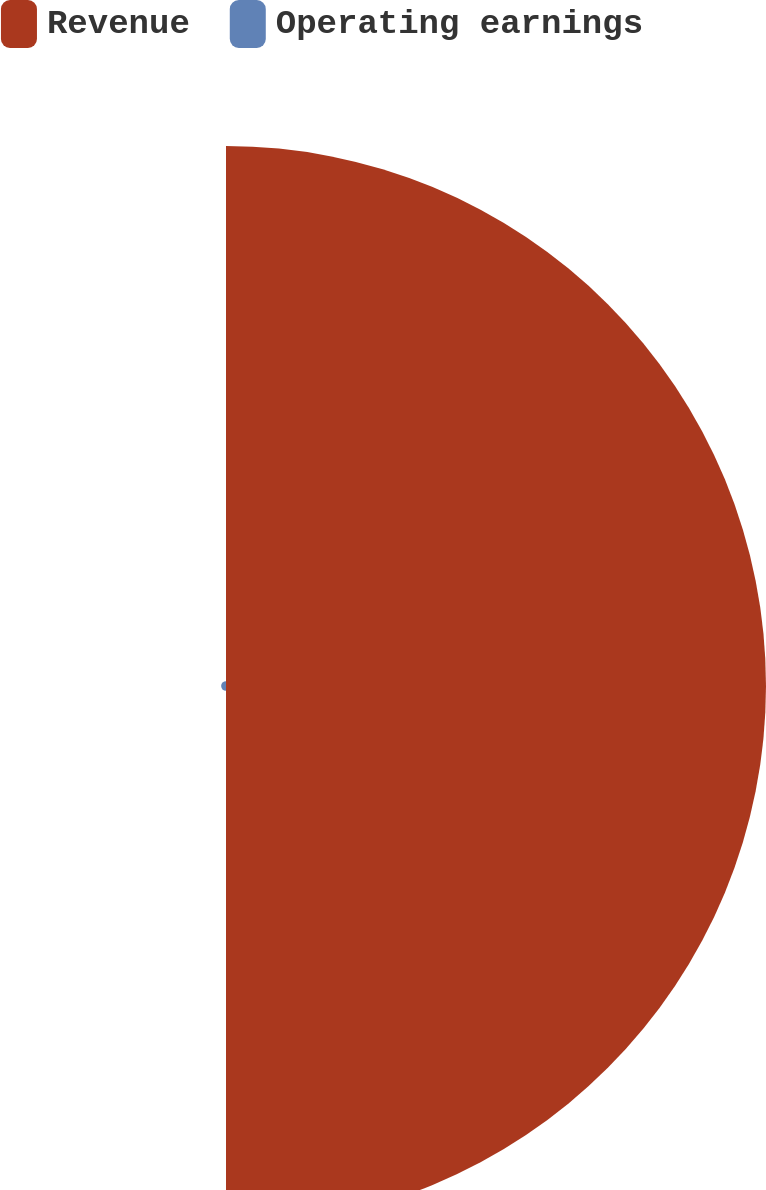<chart> <loc_0><loc_0><loc_500><loc_500><pie_chart><fcel>Revenue<fcel>Operating earnings<nl><fcel>99.11%<fcel>0.89%<nl></chart> 